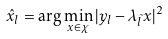Convert formula to latex. <formula><loc_0><loc_0><loc_500><loc_500>\hat { x } _ { l } = \arg \min _ { x \in \chi } | y _ { l } - \lambda _ { \tilde { l } } x | ^ { 2 }</formula> 